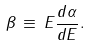<formula> <loc_0><loc_0><loc_500><loc_500>\beta \, \equiv \, E \frac { d \alpha } { d E } .</formula> 